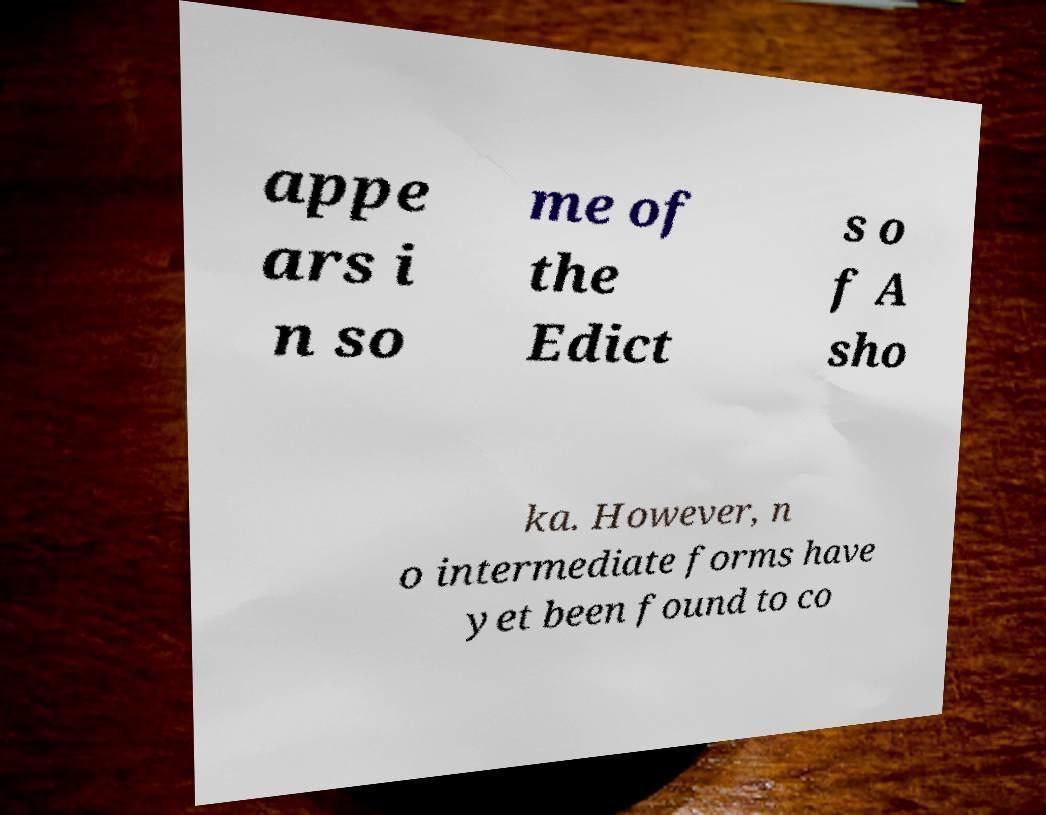Please identify and transcribe the text found in this image. appe ars i n so me of the Edict s o f A sho ka. However, n o intermediate forms have yet been found to co 